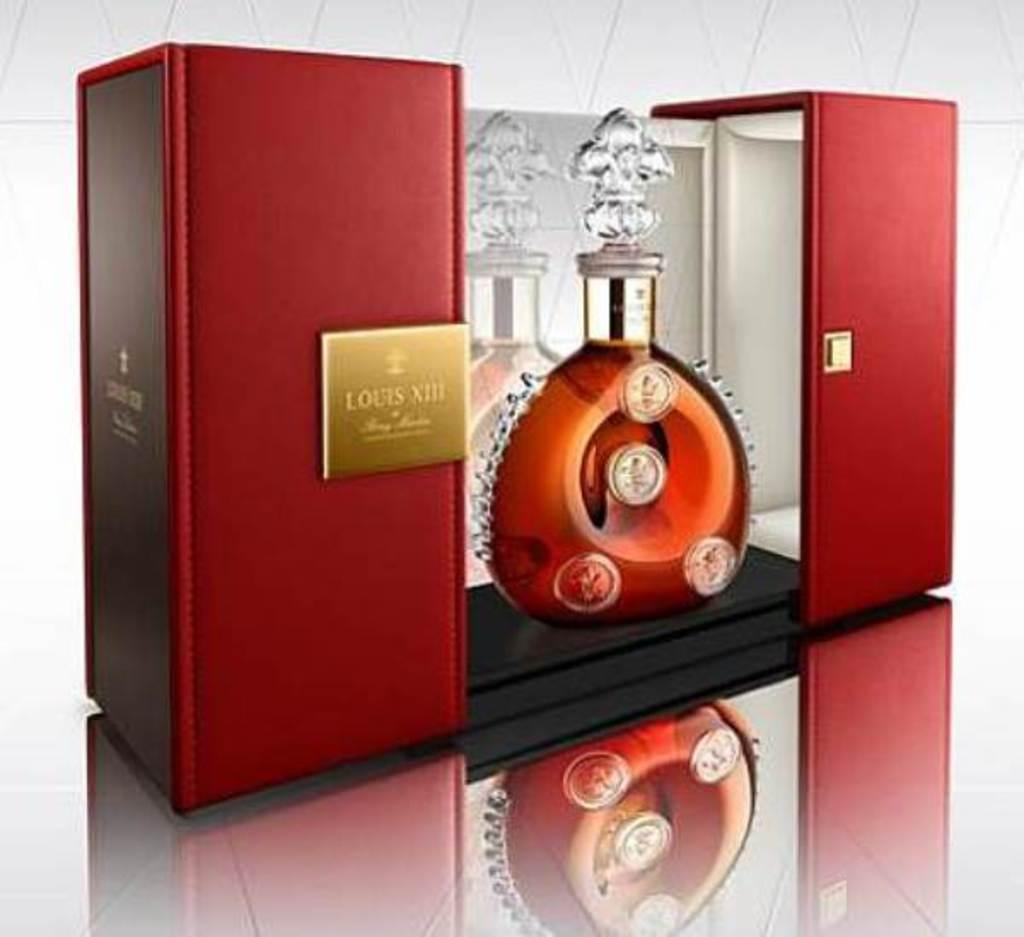<image>
Provide a brief description of the given image. A very expensive bottle of some type of liquor has a Louis XIII inscribed on a plaque. 